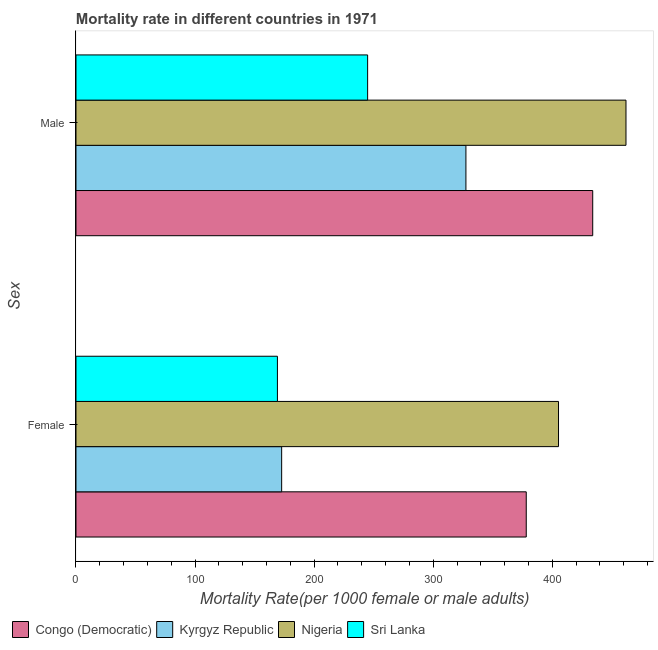How many groups of bars are there?
Offer a very short reply. 2. What is the label of the 1st group of bars from the top?
Offer a very short reply. Male. What is the male mortality rate in Congo (Democratic)?
Your answer should be compact. 433.94. Across all countries, what is the maximum female mortality rate?
Make the answer very short. 405.22. Across all countries, what is the minimum female mortality rate?
Make the answer very short. 169.17. In which country was the female mortality rate maximum?
Give a very brief answer. Nigeria. In which country was the male mortality rate minimum?
Provide a succinct answer. Sri Lanka. What is the total male mortality rate in the graph?
Keep it short and to the point. 1468.21. What is the difference between the female mortality rate in Kyrgyz Republic and that in Nigeria?
Make the answer very short. -232.5. What is the difference between the male mortality rate in Nigeria and the female mortality rate in Sri Lanka?
Give a very brief answer. 292.72. What is the average male mortality rate per country?
Your answer should be compact. 367.05. What is the difference between the female mortality rate and male mortality rate in Nigeria?
Make the answer very short. -56.67. In how many countries, is the female mortality rate greater than 280 ?
Keep it short and to the point. 2. What is the ratio of the female mortality rate in Nigeria to that in Congo (Democratic)?
Give a very brief answer. 1.07. Is the male mortality rate in Congo (Democratic) less than that in Sri Lanka?
Give a very brief answer. No. What does the 1st bar from the top in Male represents?
Offer a terse response. Sri Lanka. What does the 1st bar from the bottom in Male represents?
Keep it short and to the point. Congo (Democratic). How many bars are there?
Ensure brevity in your answer.  8. Does the graph contain grids?
Give a very brief answer. No. Where does the legend appear in the graph?
Keep it short and to the point. Bottom left. How are the legend labels stacked?
Your response must be concise. Horizontal. What is the title of the graph?
Your response must be concise. Mortality rate in different countries in 1971. Does "Malaysia" appear as one of the legend labels in the graph?
Offer a terse response. No. What is the label or title of the X-axis?
Offer a terse response. Mortality Rate(per 1000 female or male adults). What is the label or title of the Y-axis?
Keep it short and to the point. Sex. What is the Mortality Rate(per 1000 female or male adults) in Congo (Democratic) in Female?
Make the answer very short. 378.12. What is the Mortality Rate(per 1000 female or male adults) of Kyrgyz Republic in Female?
Keep it short and to the point. 172.72. What is the Mortality Rate(per 1000 female or male adults) in Nigeria in Female?
Provide a short and direct response. 405.22. What is the Mortality Rate(per 1000 female or male adults) in Sri Lanka in Female?
Your answer should be very brief. 169.17. What is the Mortality Rate(per 1000 female or male adults) in Congo (Democratic) in Male?
Provide a short and direct response. 433.94. What is the Mortality Rate(per 1000 female or male adults) in Kyrgyz Republic in Male?
Offer a very short reply. 327.47. What is the Mortality Rate(per 1000 female or male adults) in Nigeria in Male?
Ensure brevity in your answer.  461.89. What is the Mortality Rate(per 1000 female or male adults) in Sri Lanka in Male?
Offer a very short reply. 244.91. Across all Sex, what is the maximum Mortality Rate(per 1000 female or male adults) in Congo (Democratic)?
Provide a succinct answer. 433.94. Across all Sex, what is the maximum Mortality Rate(per 1000 female or male adults) of Kyrgyz Republic?
Give a very brief answer. 327.47. Across all Sex, what is the maximum Mortality Rate(per 1000 female or male adults) of Nigeria?
Give a very brief answer. 461.89. Across all Sex, what is the maximum Mortality Rate(per 1000 female or male adults) in Sri Lanka?
Keep it short and to the point. 244.91. Across all Sex, what is the minimum Mortality Rate(per 1000 female or male adults) in Congo (Democratic)?
Your response must be concise. 378.12. Across all Sex, what is the minimum Mortality Rate(per 1000 female or male adults) of Kyrgyz Republic?
Ensure brevity in your answer.  172.72. Across all Sex, what is the minimum Mortality Rate(per 1000 female or male adults) in Nigeria?
Offer a terse response. 405.22. Across all Sex, what is the minimum Mortality Rate(per 1000 female or male adults) of Sri Lanka?
Offer a very short reply. 169.17. What is the total Mortality Rate(per 1000 female or male adults) of Congo (Democratic) in the graph?
Ensure brevity in your answer.  812.06. What is the total Mortality Rate(per 1000 female or male adults) of Kyrgyz Republic in the graph?
Give a very brief answer. 500.19. What is the total Mortality Rate(per 1000 female or male adults) of Nigeria in the graph?
Keep it short and to the point. 867.11. What is the total Mortality Rate(per 1000 female or male adults) of Sri Lanka in the graph?
Your response must be concise. 414.08. What is the difference between the Mortality Rate(per 1000 female or male adults) of Congo (Democratic) in Female and that in Male?
Offer a terse response. -55.82. What is the difference between the Mortality Rate(per 1000 female or male adults) in Kyrgyz Republic in Female and that in Male?
Keep it short and to the point. -154.74. What is the difference between the Mortality Rate(per 1000 female or male adults) of Nigeria in Female and that in Male?
Your answer should be compact. -56.67. What is the difference between the Mortality Rate(per 1000 female or male adults) of Sri Lanka in Female and that in Male?
Offer a very short reply. -75.75. What is the difference between the Mortality Rate(per 1000 female or male adults) in Congo (Democratic) in Female and the Mortality Rate(per 1000 female or male adults) in Kyrgyz Republic in Male?
Your response must be concise. 50.65. What is the difference between the Mortality Rate(per 1000 female or male adults) in Congo (Democratic) in Female and the Mortality Rate(per 1000 female or male adults) in Nigeria in Male?
Offer a very short reply. -83.77. What is the difference between the Mortality Rate(per 1000 female or male adults) in Congo (Democratic) in Female and the Mortality Rate(per 1000 female or male adults) in Sri Lanka in Male?
Offer a very short reply. 133.21. What is the difference between the Mortality Rate(per 1000 female or male adults) in Kyrgyz Republic in Female and the Mortality Rate(per 1000 female or male adults) in Nigeria in Male?
Offer a terse response. -289.17. What is the difference between the Mortality Rate(per 1000 female or male adults) of Kyrgyz Republic in Female and the Mortality Rate(per 1000 female or male adults) of Sri Lanka in Male?
Your answer should be very brief. -72.19. What is the difference between the Mortality Rate(per 1000 female or male adults) of Nigeria in Female and the Mortality Rate(per 1000 female or male adults) of Sri Lanka in Male?
Your answer should be very brief. 160.31. What is the average Mortality Rate(per 1000 female or male adults) in Congo (Democratic) per Sex?
Your response must be concise. 406.03. What is the average Mortality Rate(per 1000 female or male adults) in Kyrgyz Republic per Sex?
Offer a terse response. 250.1. What is the average Mortality Rate(per 1000 female or male adults) of Nigeria per Sex?
Your answer should be compact. 433.56. What is the average Mortality Rate(per 1000 female or male adults) in Sri Lanka per Sex?
Your answer should be compact. 207.04. What is the difference between the Mortality Rate(per 1000 female or male adults) of Congo (Democratic) and Mortality Rate(per 1000 female or male adults) of Kyrgyz Republic in Female?
Give a very brief answer. 205.4. What is the difference between the Mortality Rate(per 1000 female or male adults) in Congo (Democratic) and Mortality Rate(per 1000 female or male adults) in Nigeria in Female?
Your response must be concise. -27.1. What is the difference between the Mortality Rate(per 1000 female or male adults) in Congo (Democratic) and Mortality Rate(per 1000 female or male adults) in Sri Lanka in Female?
Provide a succinct answer. 208.95. What is the difference between the Mortality Rate(per 1000 female or male adults) in Kyrgyz Republic and Mortality Rate(per 1000 female or male adults) in Nigeria in Female?
Offer a very short reply. -232.5. What is the difference between the Mortality Rate(per 1000 female or male adults) of Kyrgyz Republic and Mortality Rate(per 1000 female or male adults) of Sri Lanka in Female?
Ensure brevity in your answer.  3.56. What is the difference between the Mortality Rate(per 1000 female or male adults) of Nigeria and Mortality Rate(per 1000 female or male adults) of Sri Lanka in Female?
Give a very brief answer. 236.05. What is the difference between the Mortality Rate(per 1000 female or male adults) in Congo (Democratic) and Mortality Rate(per 1000 female or male adults) in Kyrgyz Republic in Male?
Offer a very short reply. 106.47. What is the difference between the Mortality Rate(per 1000 female or male adults) in Congo (Democratic) and Mortality Rate(per 1000 female or male adults) in Nigeria in Male?
Provide a short and direct response. -27.95. What is the difference between the Mortality Rate(per 1000 female or male adults) of Congo (Democratic) and Mortality Rate(per 1000 female or male adults) of Sri Lanka in Male?
Your answer should be very brief. 189.03. What is the difference between the Mortality Rate(per 1000 female or male adults) in Kyrgyz Republic and Mortality Rate(per 1000 female or male adults) in Nigeria in Male?
Make the answer very short. -134.42. What is the difference between the Mortality Rate(per 1000 female or male adults) in Kyrgyz Republic and Mortality Rate(per 1000 female or male adults) in Sri Lanka in Male?
Make the answer very short. 82.55. What is the difference between the Mortality Rate(per 1000 female or male adults) in Nigeria and Mortality Rate(per 1000 female or male adults) in Sri Lanka in Male?
Make the answer very short. 216.98. What is the ratio of the Mortality Rate(per 1000 female or male adults) in Congo (Democratic) in Female to that in Male?
Your response must be concise. 0.87. What is the ratio of the Mortality Rate(per 1000 female or male adults) in Kyrgyz Republic in Female to that in Male?
Give a very brief answer. 0.53. What is the ratio of the Mortality Rate(per 1000 female or male adults) in Nigeria in Female to that in Male?
Your response must be concise. 0.88. What is the ratio of the Mortality Rate(per 1000 female or male adults) in Sri Lanka in Female to that in Male?
Your answer should be very brief. 0.69. What is the difference between the highest and the second highest Mortality Rate(per 1000 female or male adults) in Congo (Democratic)?
Your answer should be very brief. 55.82. What is the difference between the highest and the second highest Mortality Rate(per 1000 female or male adults) in Kyrgyz Republic?
Make the answer very short. 154.74. What is the difference between the highest and the second highest Mortality Rate(per 1000 female or male adults) in Nigeria?
Offer a terse response. 56.67. What is the difference between the highest and the second highest Mortality Rate(per 1000 female or male adults) of Sri Lanka?
Your response must be concise. 75.75. What is the difference between the highest and the lowest Mortality Rate(per 1000 female or male adults) in Congo (Democratic)?
Provide a succinct answer. 55.82. What is the difference between the highest and the lowest Mortality Rate(per 1000 female or male adults) of Kyrgyz Republic?
Make the answer very short. 154.74. What is the difference between the highest and the lowest Mortality Rate(per 1000 female or male adults) of Nigeria?
Provide a short and direct response. 56.67. What is the difference between the highest and the lowest Mortality Rate(per 1000 female or male adults) in Sri Lanka?
Your answer should be compact. 75.75. 